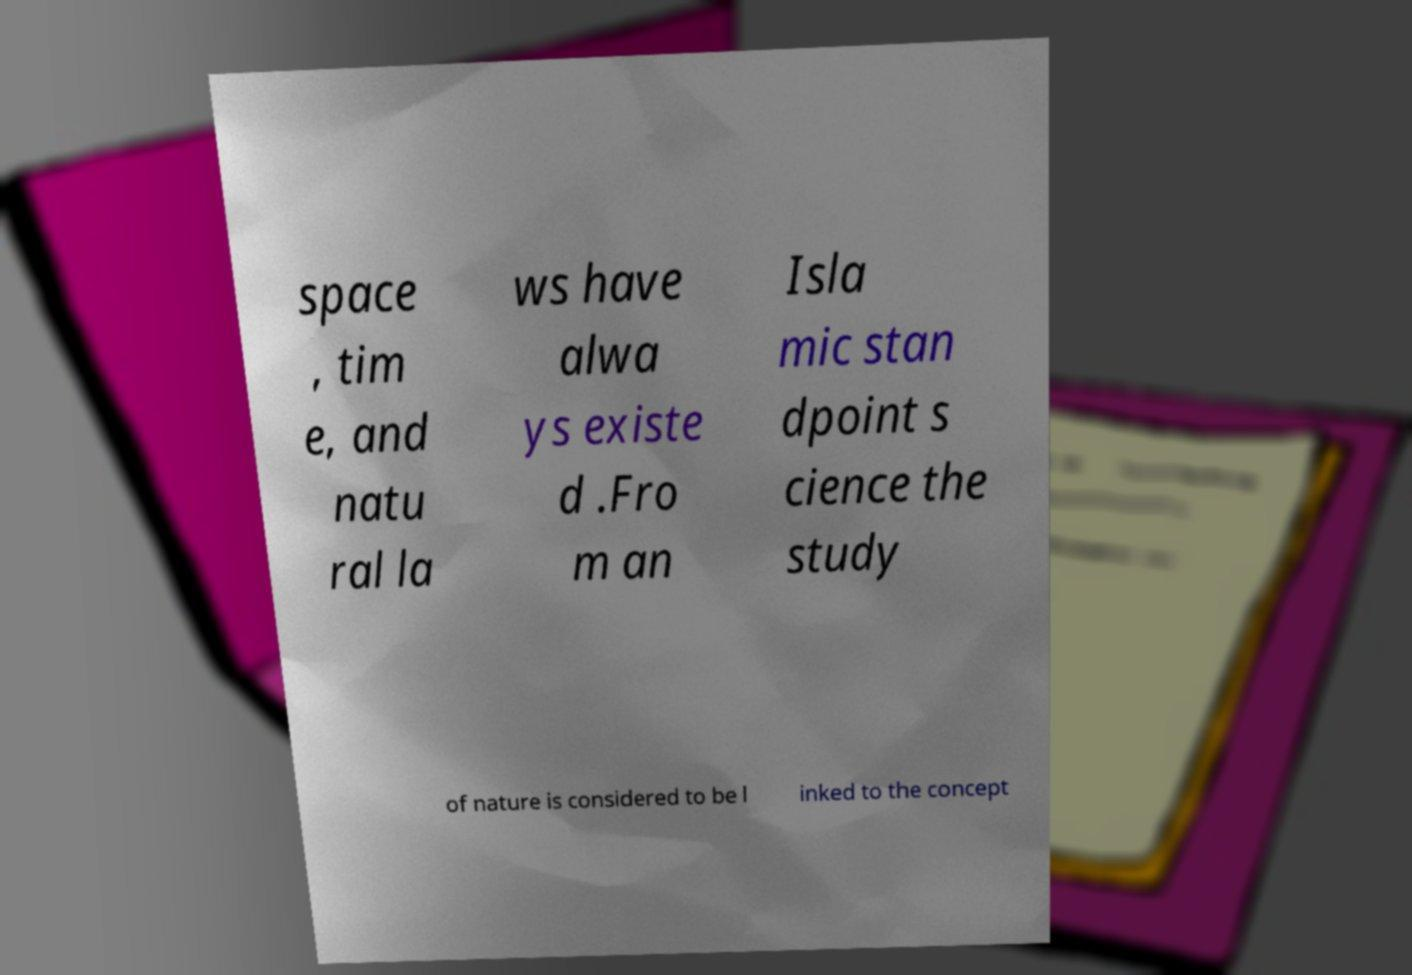Could you extract and type out the text from this image? space , tim e, and natu ral la ws have alwa ys existe d .Fro m an Isla mic stan dpoint s cience the study of nature is considered to be l inked to the concept 